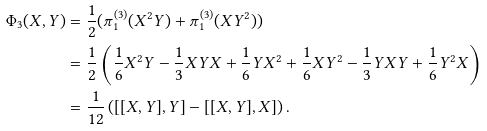Convert formula to latex. <formula><loc_0><loc_0><loc_500><loc_500>\Phi _ { 3 } ( X , Y ) & = \frac { 1 } { 2 } ( \pi _ { 1 } ^ { ( 3 ) } ( X ^ { 2 } Y ) + \pi _ { 1 } ^ { ( 3 ) } ( X Y ^ { 2 } ) ) \\ & = \frac { 1 } { 2 } \left ( \frac { 1 } { 6 } X ^ { 2 } Y - \frac { 1 } { 3 } X Y X + \frac { 1 } { 6 } Y X ^ { 2 } + \frac { 1 } { 6 } X Y ^ { 2 } - \frac { 1 } { 3 } Y X Y + \frac { 1 } { 6 } Y ^ { 2 } X \right ) \\ & = \frac { 1 } { 1 2 } \left ( [ [ X , Y ] , Y ] - [ [ X , Y ] , X ] \right ) .</formula> 